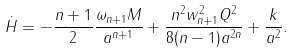Convert formula to latex. <formula><loc_0><loc_0><loc_500><loc_500>\dot { H } = - { \frac { n + 1 } { 2 } } { \frac { \omega _ { n + 1 } M } { a ^ { n + 1 } } } + { \frac { n ^ { 2 } w _ { n + 1 } ^ { 2 } Q ^ { 2 } } { 8 ( n - 1 ) a ^ { 2 n } } } + { \frac { k } { a ^ { 2 } } } .</formula> 